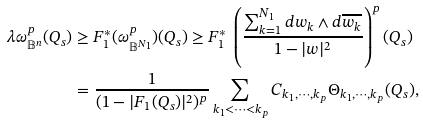<formula> <loc_0><loc_0><loc_500><loc_500>\lambda \omega ^ { p } _ { \mathbb { B } ^ { n } } ( Q _ { s } ) & \geq F _ { 1 } ^ { * } ( \omega ^ { p } _ { \mathbb { B } ^ { N _ { 1 } } } ) ( Q _ { s } ) \geq F _ { 1 } ^ { * } \ \left ( \frac { \sum _ { k = 1 } ^ { N _ { 1 } } d w _ { k } \wedge d \overline { w _ { k } } } { 1 - | w | ^ { 2 } } \right ) ^ { p } ( Q _ { s } ) \\ & = \frac { 1 } { ( 1 - | F _ { 1 } ( Q _ { s } ) | ^ { 2 } ) ^ { p } } \sum _ { k _ { 1 } < \cdots < k _ { p } } C _ { k _ { 1 } , \cdots , k _ { p } } \Theta _ { k _ { 1 } , \cdots , k _ { p } } ( Q _ { s } ) ,</formula> 